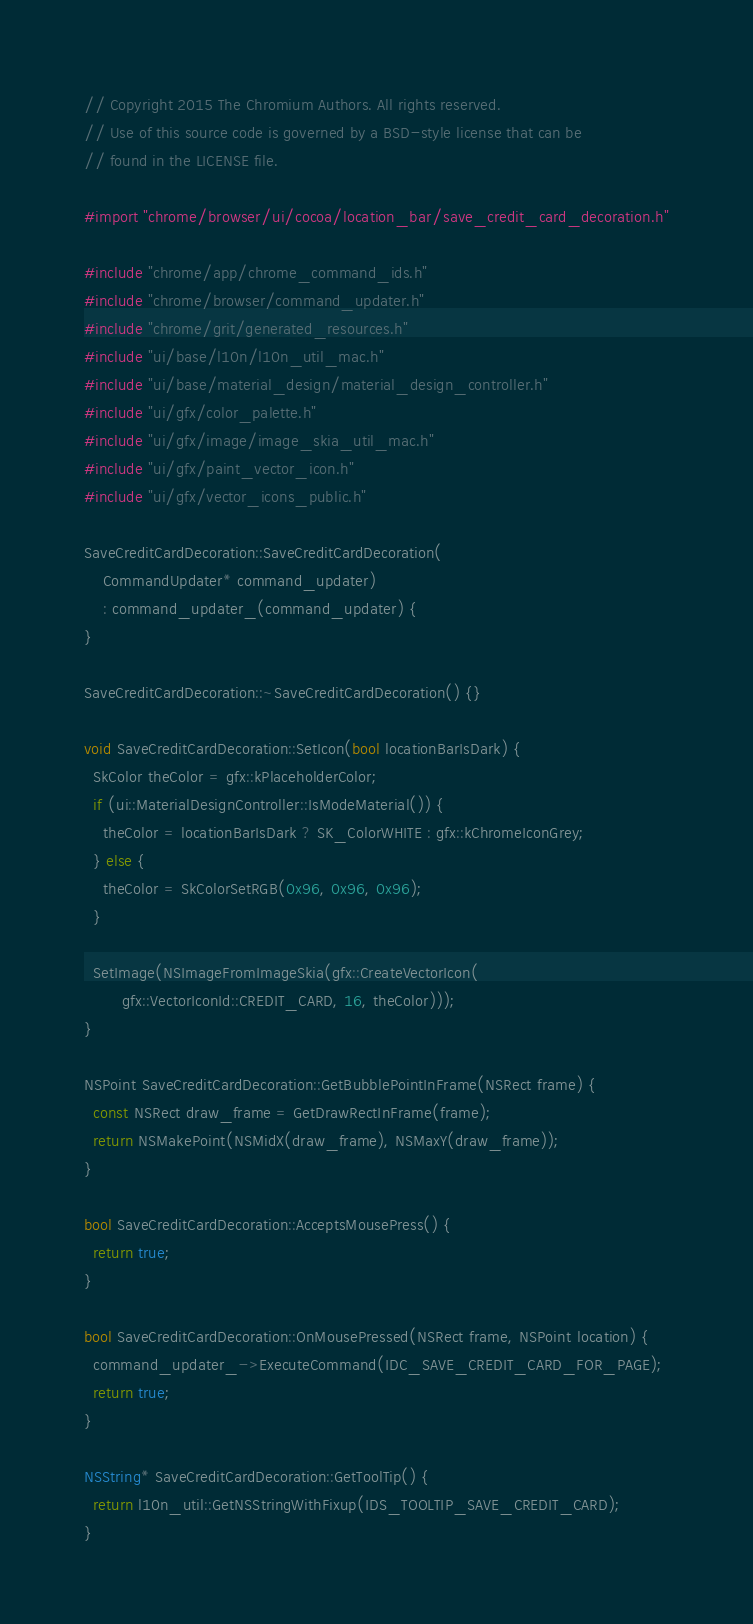Convert code to text. <code><loc_0><loc_0><loc_500><loc_500><_ObjectiveC_>// Copyright 2015 The Chromium Authors. All rights reserved.
// Use of this source code is governed by a BSD-style license that can be
// found in the LICENSE file.

#import "chrome/browser/ui/cocoa/location_bar/save_credit_card_decoration.h"

#include "chrome/app/chrome_command_ids.h"
#include "chrome/browser/command_updater.h"
#include "chrome/grit/generated_resources.h"
#include "ui/base/l10n/l10n_util_mac.h"
#include "ui/base/material_design/material_design_controller.h"
#include "ui/gfx/color_palette.h"
#include "ui/gfx/image/image_skia_util_mac.h"
#include "ui/gfx/paint_vector_icon.h"
#include "ui/gfx/vector_icons_public.h"

SaveCreditCardDecoration::SaveCreditCardDecoration(
    CommandUpdater* command_updater)
    : command_updater_(command_updater) {
}

SaveCreditCardDecoration::~SaveCreditCardDecoration() {}

void SaveCreditCardDecoration::SetIcon(bool locationBarIsDark) {
  SkColor theColor = gfx::kPlaceholderColor;
  if (ui::MaterialDesignController::IsModeMaterial()) {
    theColor = locationBarIsDark ? SK_ColorWHITE : gfx::kChromeIconGrey;
  } else {
    theColor = SkColorSetRGB(0x96, 0x96, 0x96);
  }

  SetImage(NSImageFromImageSkia(gfx::CreateVectorIcon(
        gfx::VectorIconId::CREDIT_CARD, 16, theColor)));
}

NSPoint SaveCreditCardDecoration::GetBubblePointInFrame(NSRect frame) {
  const NSRect draw_frame = GetDrawRectInFrame(frame);
  return NSMakePoint(NSMidX(draw_frame), NSMaxY(draw_frame));
}

bool SaveCreditCardDecoration::AcceptsMousePress() {
  return true;
}

bool SaveCreditCardDecoration::OnMousePressed(NSRect frame, NSPoint location) {
  command_updater_->ExecuteCommand(IDC_SAVE_CREDIT_CARD_FOR_PAGE);
  return true;
}

NSString* SaveCreditCardDecoration::GetToolTip() {
  return l10n_util::GetNSStringWithFixup(IDS_TOOLTIP_SAVE_CREDIT_CARD);
}
</code> 